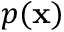<formula> <loc_0><loc_0><loc_500><loc_500>p ( \mathbf x )</formula> 